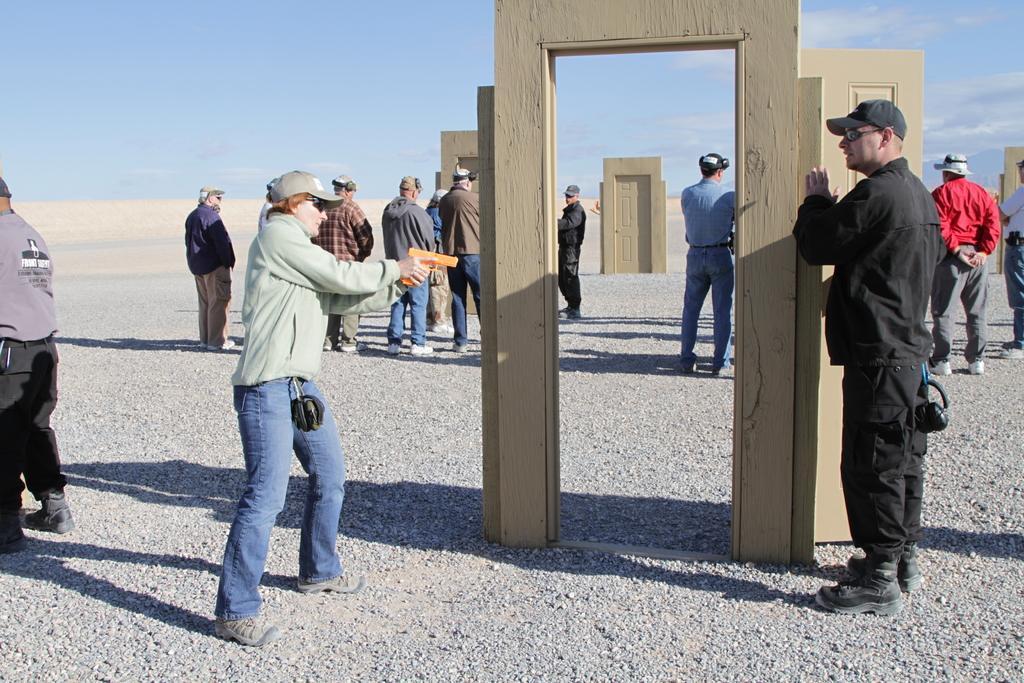Could you give a brief overview of what you see in this image? In this image we can see a group of people wearing caps are standing. One person is holding a gun in his hands, some persons are wearing headphones. In the background, we can see some doors placed on the ground and the sky. 